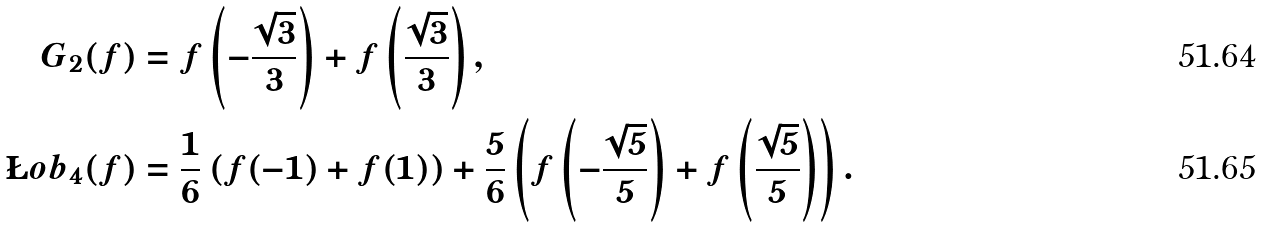Convert formula to latex. <formula><loc_0><loc_0><loc_500><loc_500>\ G _ { 2 } ( f ) & = f \left ( - \frac { \sqrt { 3 } } { 3 } \right ) + f \left ( \frac { \sqrt { 3 } } { 3 } \right ) , \\ \L o b _ { 4 } ( f ) & = \frac { 1 } { 6 } \left ( f ( - 1 ) + f ( 1 ) \right ) + \frac { 5 } { 6 } \left ( f \left ( - \frac { \sqrt { 5 } } { 5 } \right ) + f \left ( \frac { \sqrt { 5 } } { 5 } \right ) \right ) .</formula> 